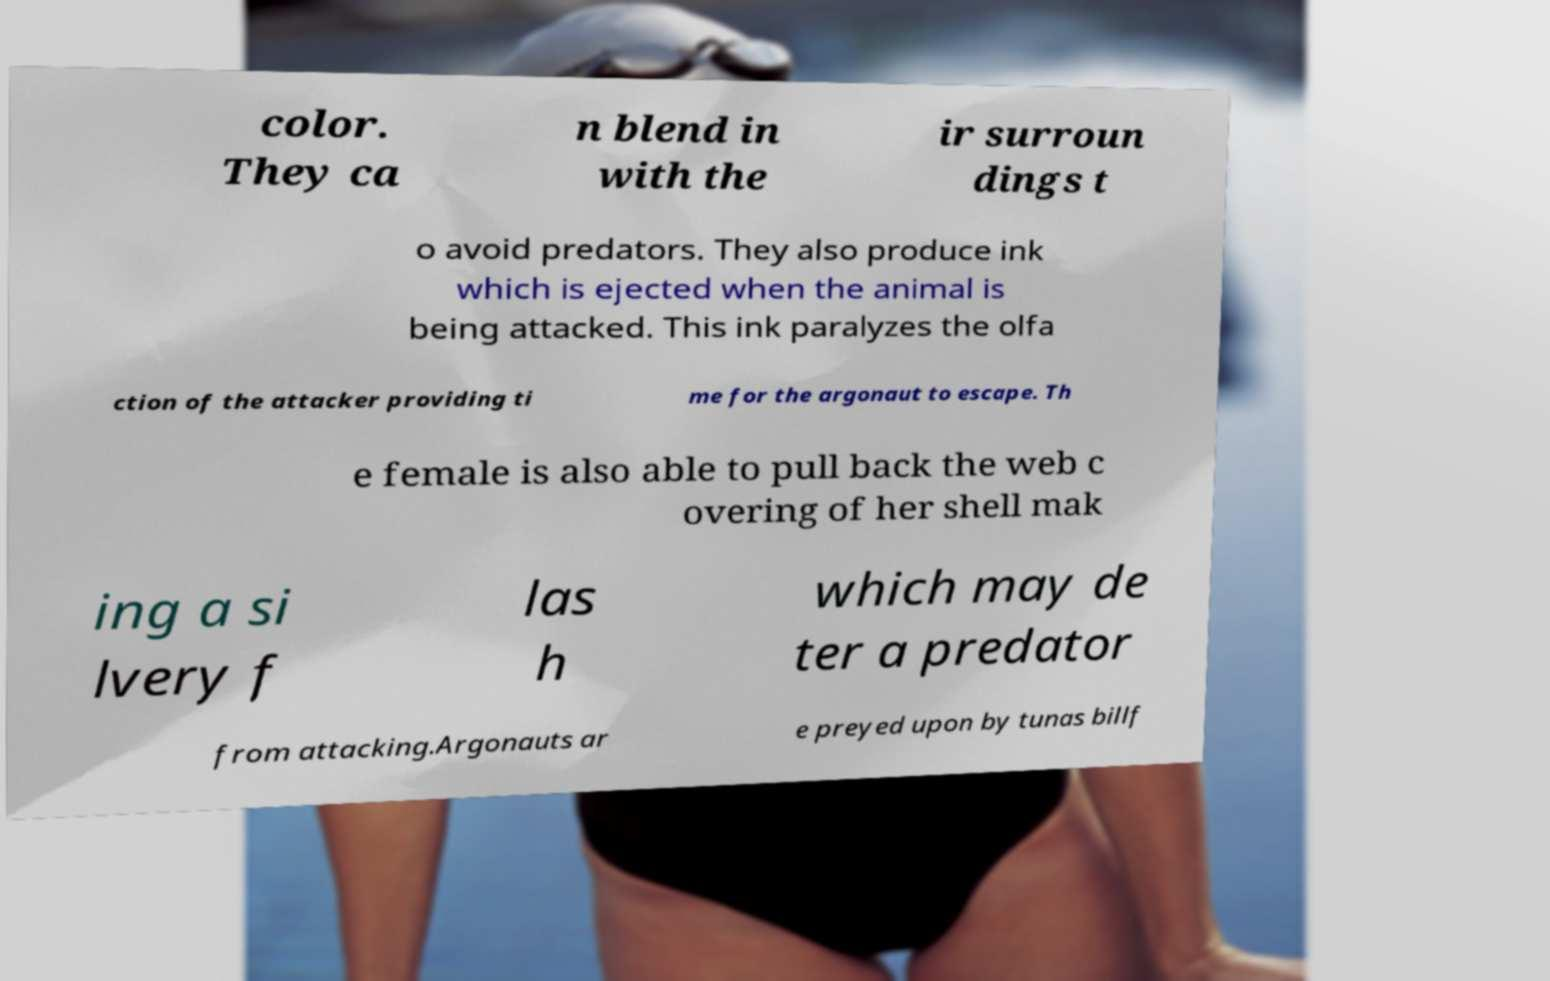Please read and relay the text visible in this image. What does it say? color. They ca n blend in with the ir surroun dings t o avoid predators. They also produce ink which is ejected when the animal is being attacked. This ink paralyzes the olfa ction of the attacker providing ti me for the argonaut to escape. Th e female is also able to pull back the web c overing of her shell mak ing a si lvery f las h which may de ter a predator from attacking.Argonauts ar e preyed upon by tunas billf 